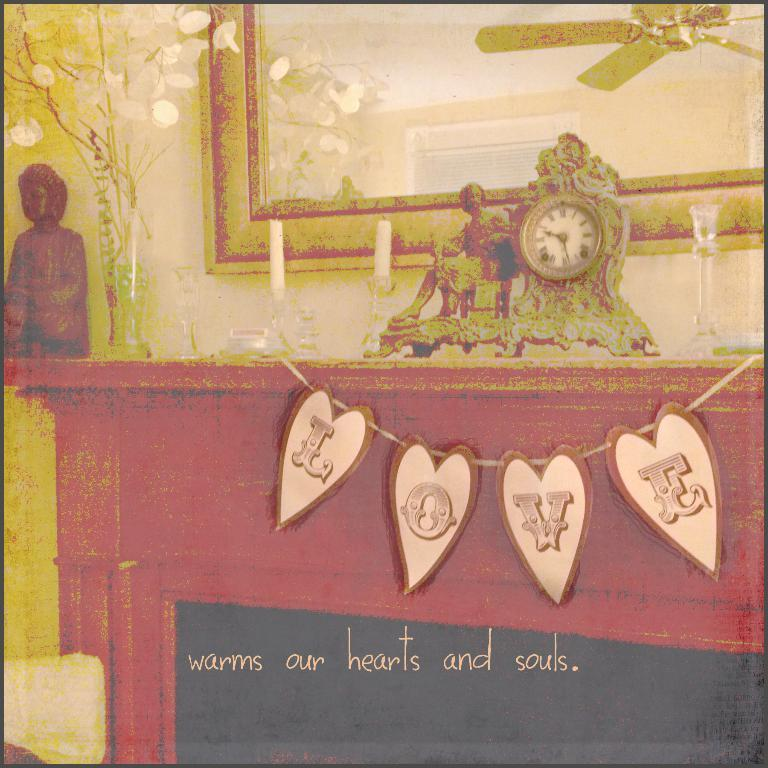Provide a one-sentence caption for the provided image. Love sign that warms our hearts and souls on the entertainment center. 